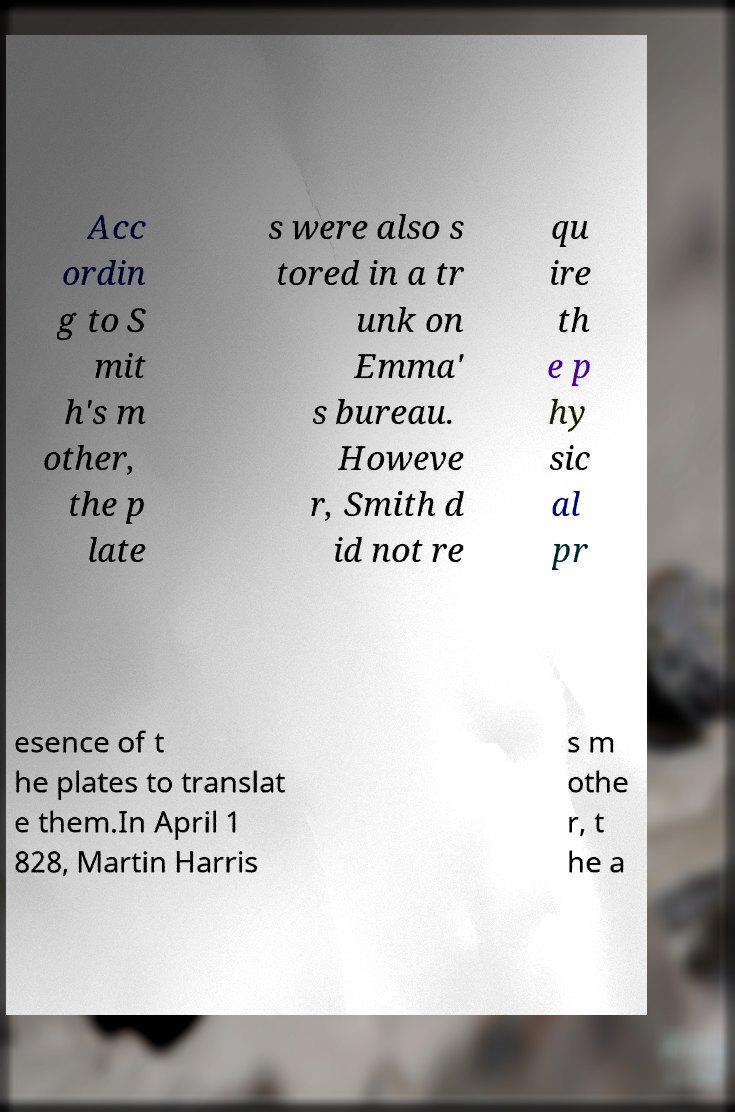I need the written content from this picture converted into text. Can you do that? Acc ordin g to S mit h's m other, the p late s were also s tored in a tr unk on Emma' s bureau. Howeve r, Smith d id not re qu ire th e p hy sic al pr esence of t he plates to translat e them.In April 1 828, Martin Harris s m othe r, t he a 